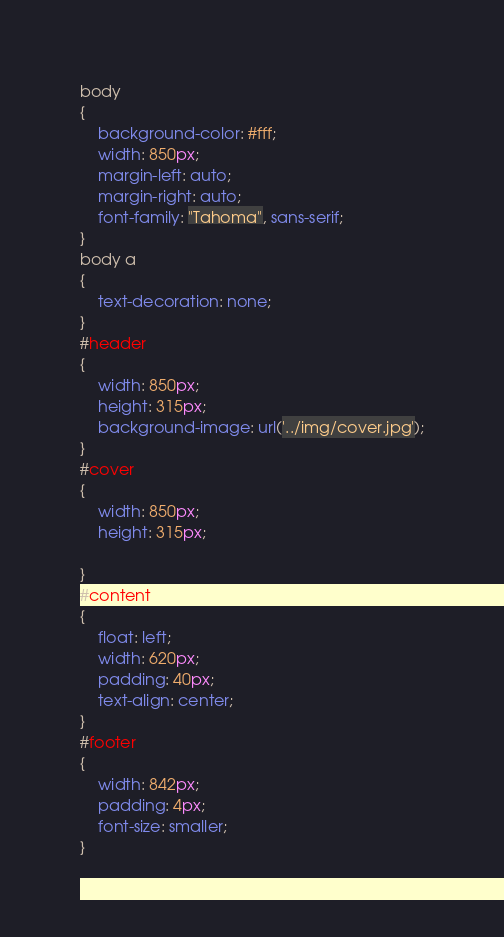Convert code to text. <code><loc_0><loc_0><loc_500><loc_500><_CSS_>body
{
    background-color: #fff;
    width: 850px;
    margin-left: auto;
    margin-right: auto;
    font-family: "Tahoma", sans-serif;
}
body a
{
    text-decoration: none;
}
#header
{
    width: 850px;
    height: 315px;
    background-image: url('../img/cover.jpg');
}
#cover
{
    width: 850px;
    height: 315px;
    
}
#content
{
    float: left;
    width: 620px;
    padding: 40px;
    text-align: center;
}
#footer
{
    width: 842px;
    padding: 4px;
    font-size: smaller;
}
</code> 